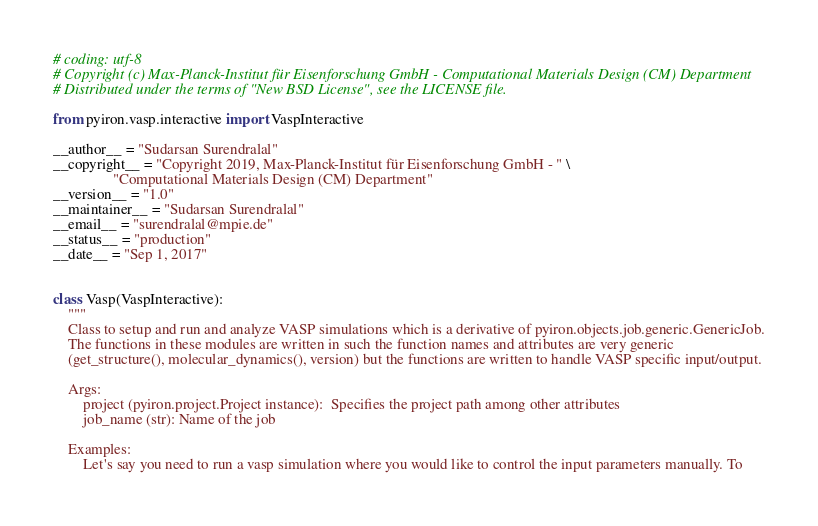<code> <loc_0><loc_0><loc_500><loc_500><_Python_># coding: utf-8
# Copyright (c) Max-Planck-Institut für Eisenforschung GmbH - Computational Materials Design (CM) Department
# Distributed under the terms of "New BSD License", see the LICENSE file.

from pyiron.vasp.interactive import VaspInteractive

__author__ = "Sudarsan Surendralal"
__copyright__ = "Copyright 2019, Max-Planck-Institut für Eisenforschung GmbH - " \
                "Computational Materials Design (CM) Department"
__version__ = "1.0"
__maintainer__ = "Sudarsan Surendralal"
__email__ = "surendralal@mpie.de"
__status__ = "production"
__date__ = "Sep 1, 2017"


class Vasp(VaspInteractive):
    """
    Class to setup and run and analyze VASP simulations which is a derivative of pyiron.objects.job.generic.GenericJob.
    The functions in these modules are written in such the function names and attributes are very generic
    (get_structure(), molecular_dynamics(), version) but the functions are written to handle VASP specific input/output.

    Args:
        project (pyiron.project.Project instance):  Specifies the project path among other attributes
        job_name (str): Name of the job

    Examples:
        Let's say you need to run a vasp simulation where you would like to control the input parameters manually. To</code> 